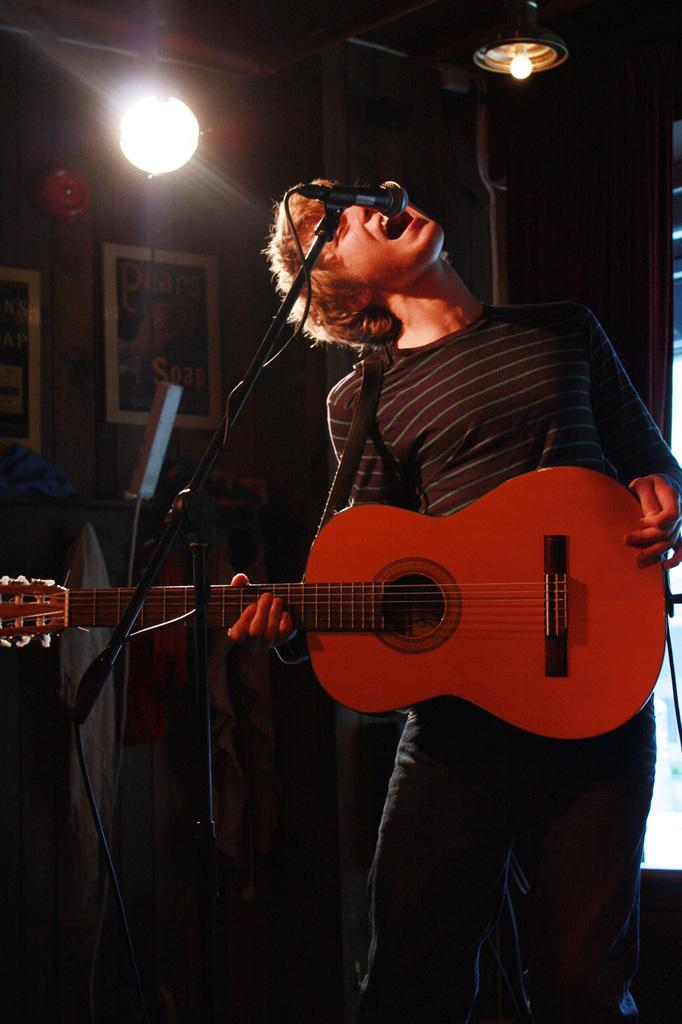What is the person in the image doing? The person is singing on a mic and playing a guitar. Can you describe the background of the image? There is a light in the background and frames on the wall. What type of prose is the person reciting while playing the guitar in the image? There is no indication in the image that the person is reciting any prose; they are singing. 